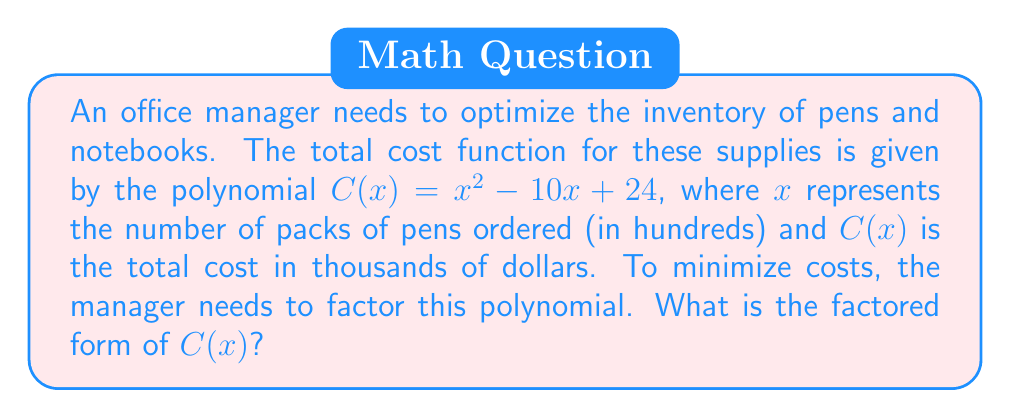Help me with this question. Let's factor the polynomial $C(x) = x^2 - 10x + 24$ step by step:

1) First, we identify that this is a quadratic polynomial in the form $ax^2 + bx + c$, where:
   $a = 1$
   $b = -10$
   $c = 24$

2) To factor this, we need to find two numbers that multiply to give $ac$ (which is 1 * 24 = 24) and add up to $b$ (-10).

3) The factors of 24 are: ±1, ±2, ±3, ±4, ±6, ±8, ±12, ±24

4) We need to find a pair that adds up to -10. The pair that works is -6 and -4.

5) We can rewrite the middle term using these numbers:
   $C(x) = x^2 - 6x - 4x + 24$

6) Now we can factor by grouping:
   $C(x) = (x^2 - 6x) + (-4x + 24)$
   $C(x) = x(x - 6) - 4(x - 6)$
   $C(x) = (x - 6)(x - 4)$

Therefore, the factored form of $C(x)$ is $(x - 6)(x - 4)$.
Answer: $(x - 6)(x - 4)$ 